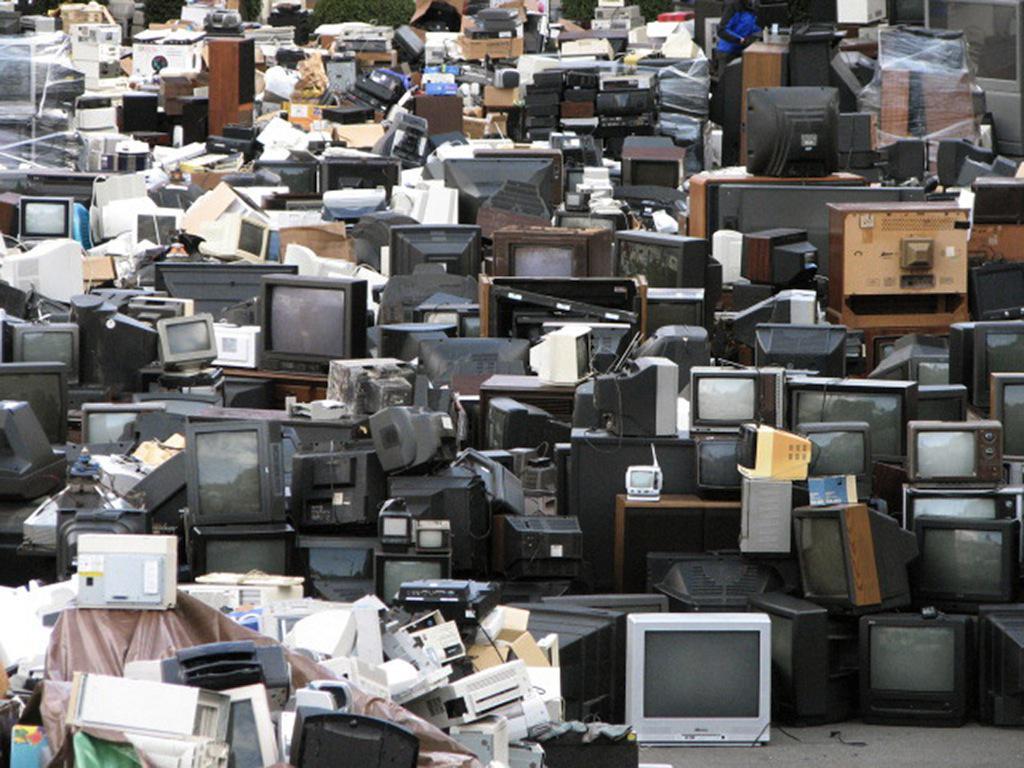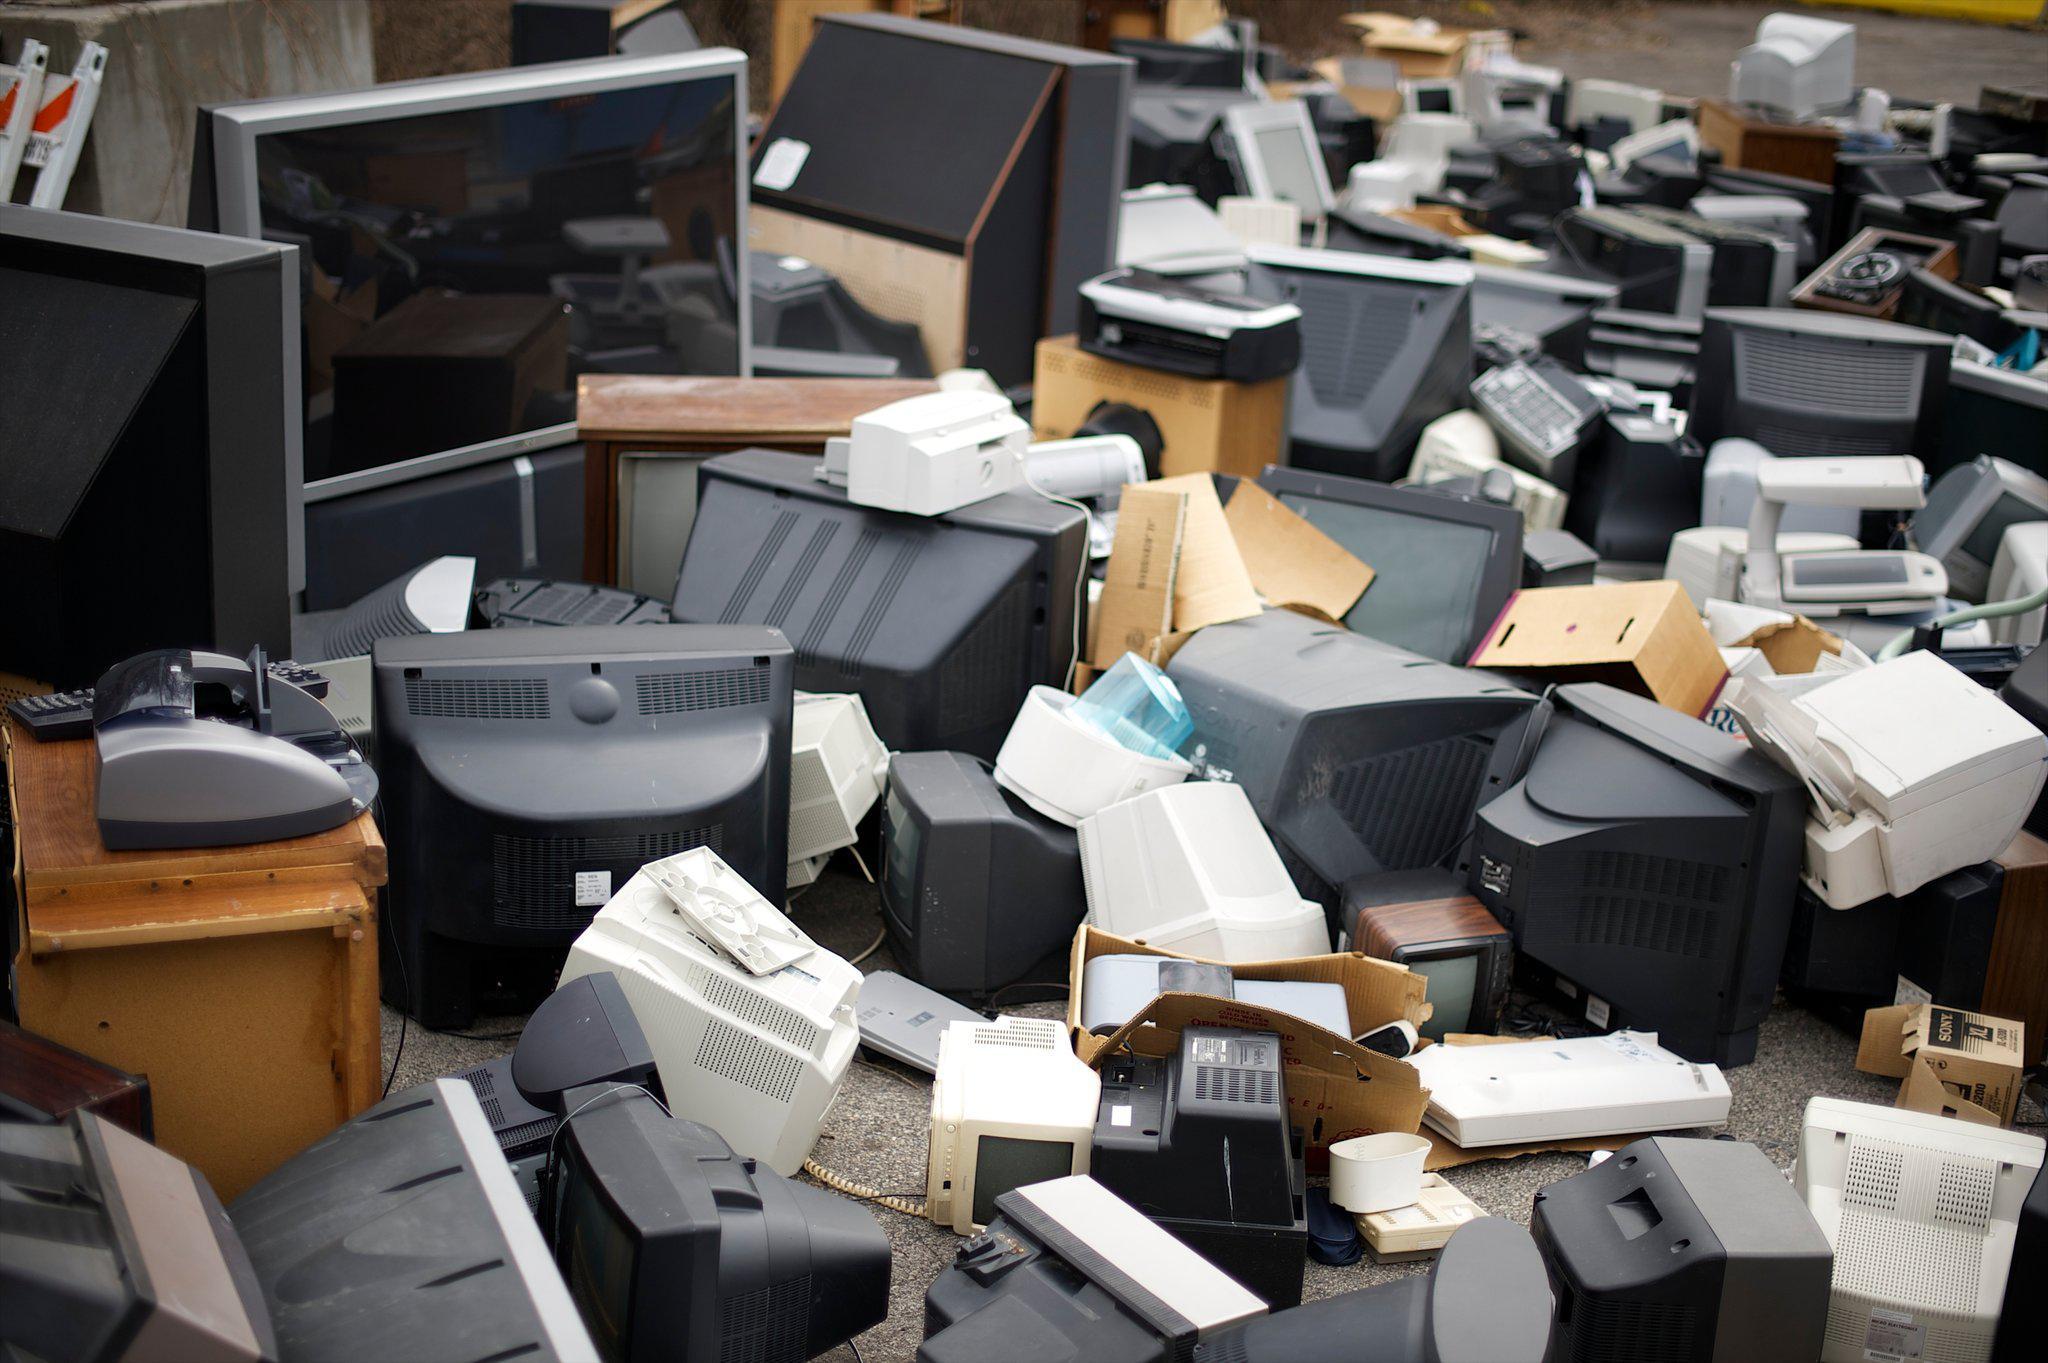The first image is the image on the left, the second image is the image on the right. Analyze the images presented: Is the assertion "At least one image shows an upward view of 'endless' stacked televisions that feature three round white knobs in a horizontal row right of the screen." valid? Answer yes or no. No. The first image is the image on the left, the second image is the image on the right. Examine the images to the left and right. Is the description "All the televisions are off." accurate? Answer yes or no. Yes. 